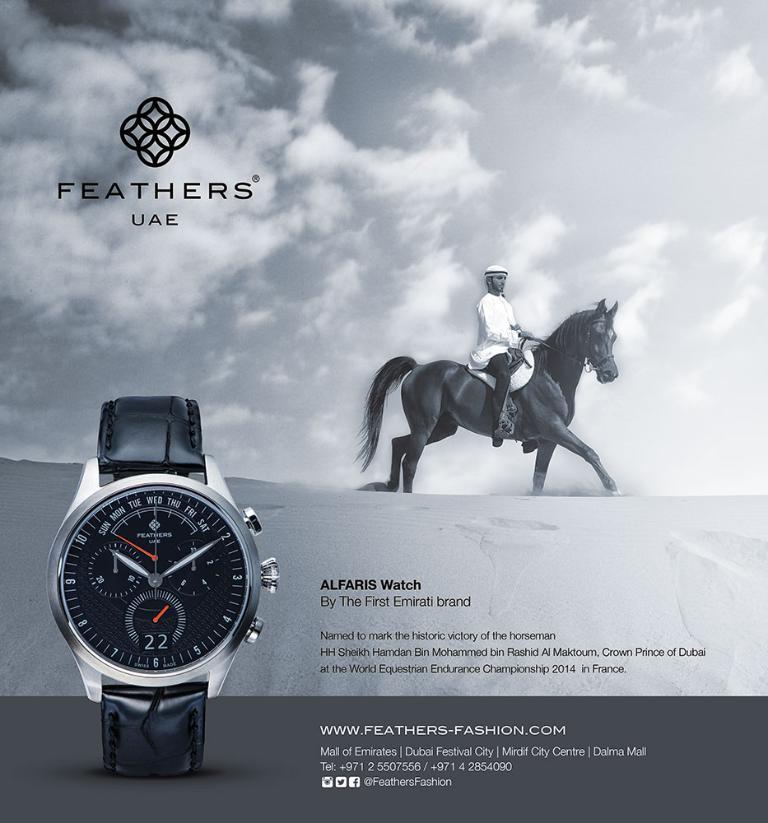What's the model name of this watch?
Provide a succinct answer. Alfaris. Which country is this model specifically for?
Keep it short and to the point. Uae. 